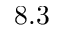<formula> <loc_0><loc_0><loc_500><loc_500>8 . 3</formula> 